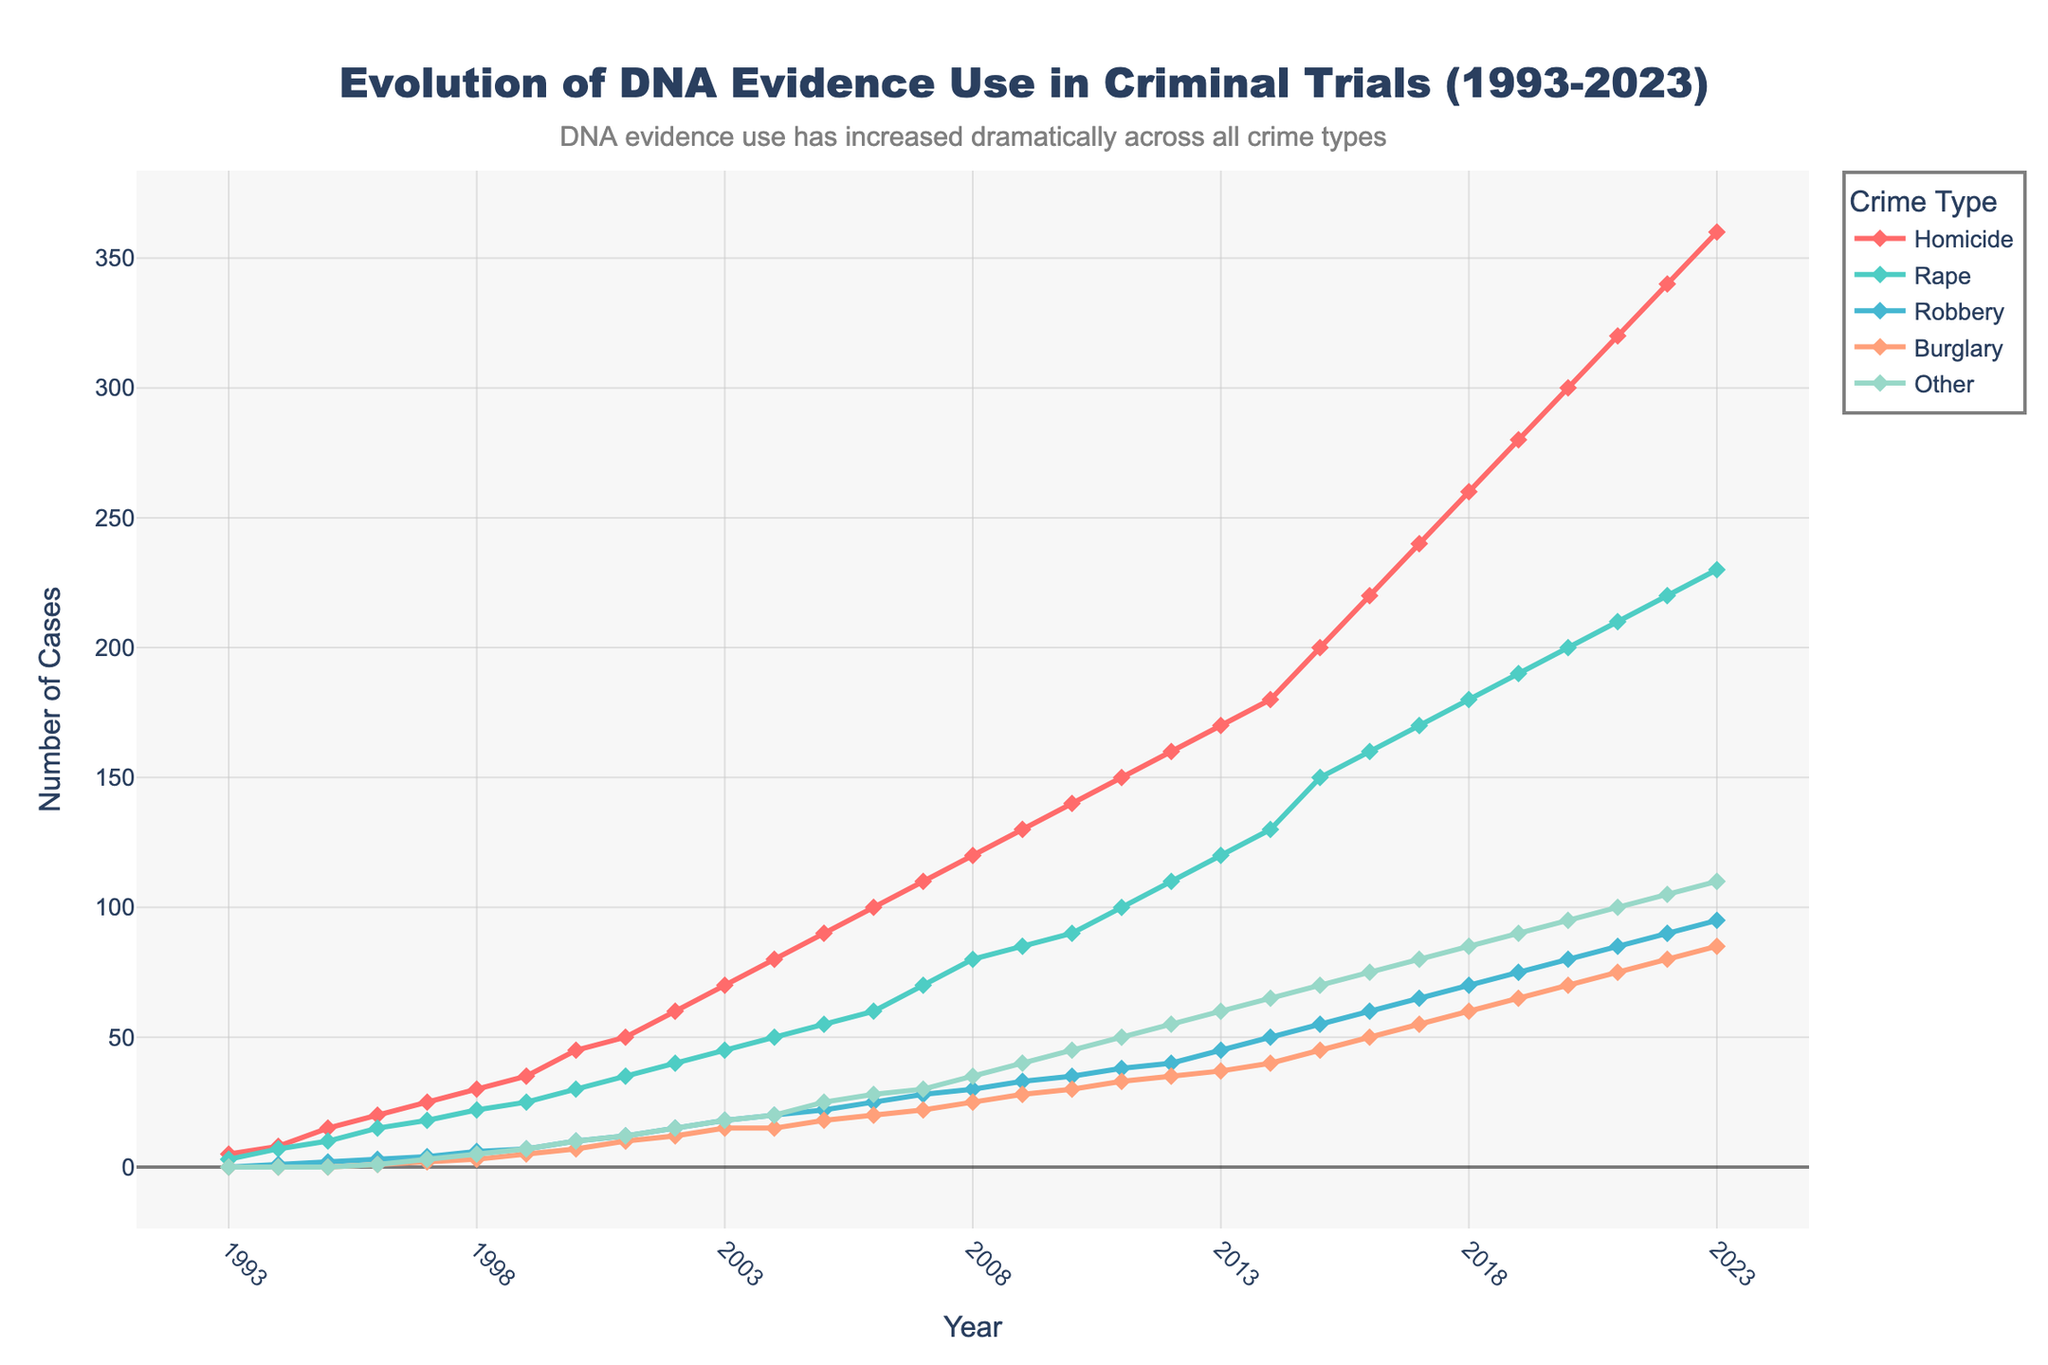What is the overall trend of DNA evidence use in criminal trials from 1993 to 2023? The overall trend can be observed by examining the slope of the lines for each crime type from 1993 to 2023. All lines show an upward trend, indicating an increase in DNA evidence use over time.
Answer: Increasing What was the number of DNA evidence cases for homicide in 2000? Locate the data point for homicide in the year 2000 on the x-axis and check the corresponding y-value. The number of homicide cases using DNA evidence in 2000 is 45.
Answer: 45 Which crime type showed the highest number of DNA evidence cases in 2023? Look at the data points in 2023 and compare the y-values for each crime type. Homicide has the highest y-value in 2023, standing at 360 cases.
Answer: Homicide How many total DNA evidence cases were there across all crime types in 2010? Sum the cases for each crime type in 2010: 140 (Homicide) + 90 (Rape) + 35 (Robbery) + 30 (Burglary) + 45 (Other). The total is 340.
Answer: 340 Considering the data from 1993 to 2023, which crime type had the smallest increase in DNA evidence use? Calculate the increase for each crime type from 1993 to 2023 by subtracting the 1993 value from the 2023 value. The smallest increase is for Robbery (95 - 0 = 95).
Answer: Robbery In what year did the number of DNA evidence cases reach 100 for rape? Locate the data point for rape and find the year when the y-value is 100. This occurs in 2011.
Answer: 2011 How does the trend in DNA evidence use for burglary compare to that for robbery? Compare the slope and overall increase of the lines for burglary and robbery. Both show an upward trend, but the increase for burglary (85 - 0 = 85) is slightly less steep than for Robbery (95 - 0 = 95).
Answer: Similar upward trend, robbery slightly higher What is the average annual increase in DNA evidence cases for homicide from 1993 to 2023? Calculate the increase from 1993 to 2023 (360 - 5 = 355) and divide by the number of years (30 years). The average annual increase is approximately 11.83 cases per year.
Answer: 11.83 By how many cases did the use of DNA evidence in trials for rape increase from 2012 to 2022? Subtract the number of cases in 2012 from the number of cases in 2022 for rape: (220 - 110). The increase is 110 cases.
Answer: 110 